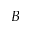Convert formula to latex. <formula><loc_0><loc_0><loc_500><loc_500>B</formula> 